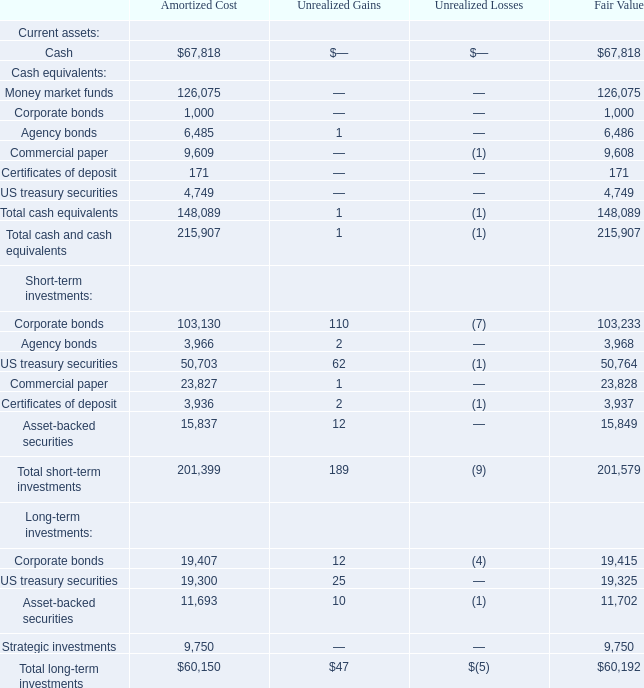5. INVESTMENTS
Investments in Marketable Securities
The Company’s investments in available-for-sale marketable securities are made pursuant to its investment policy, which has established guidelines relative to the diversification of the Company’s investments and their maturities, with the principal objective of capital preservation and maintaining liquidity sufficient to meet cash flow requirements.
The following is a summary of investments, including those that meet the definition of a cash equivalent, as of December 31, 2019 (in thousands):
What is the principal objective of the company's investments? Capital preservation and maintaining liquidity sufficient to meet cash flow requirements. What was the fair value amount of cash?
Answer scale should be: thousand. $67,818. What was the fair value of corporate bonds?
Answer scale should be: thousand. 1,000. What percentage of fair value total cash equivalents consist of agency bonds?
Answer scale should be: percent. (6,485/148,089)
Answer: 4.38. What percentage of total unrealised gains for short-term investments consist of US treasury securities?
Answer scale should be: percent. (62/189)
Answer: 32.8. What is the total amortized cost of agency bonds and corporate bonds?
Answer scale should be: thousand. 6,485+9,609
Answer: 16094. 